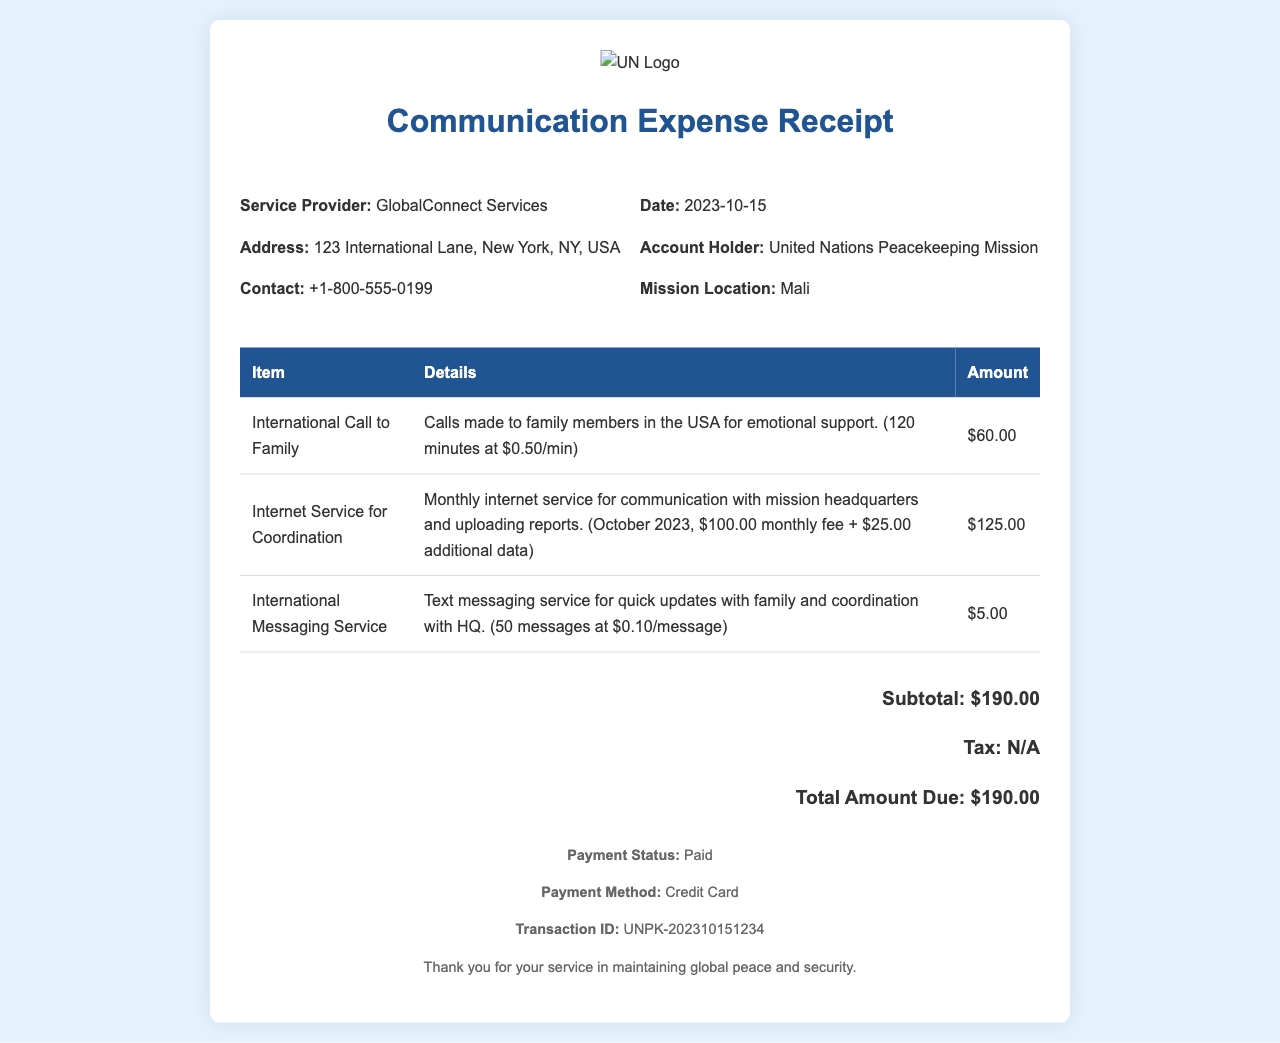What is the date of the receipt? The receipt was issued on the date mentioned in the document, which is 2023-10-15.
Answer: 2023-10-15 Who is the service provider? The name of the service provider is listed at the beginning of the details section.
Answer: GlobalConnect Services What is the total amount due? The total amount due is the final amount calculated at the bottom of the receipt.
Answer: $190.00 How much was spent on international calls to family? The amount for international calls is specified in the itemized expenses section.
Answer: $60.00 What is included in the internet service cost? The details for internet service outline both the monthly fee and additional data costs.
Answer: $100.00 monthly fee + $25.00 additional data What type of payment method was used? The payment method is mentioned in the footer section of the receipt.
Answer: Credit Card How many international minutes were used for calls? The number of minutes for calls to family is provided in the description of the expense.
Answer: 120 minutes What was the subtotal amount before tax? The subtotal is listed before any additional taxes at the bottom of the receipt.
Answer: $190.00 